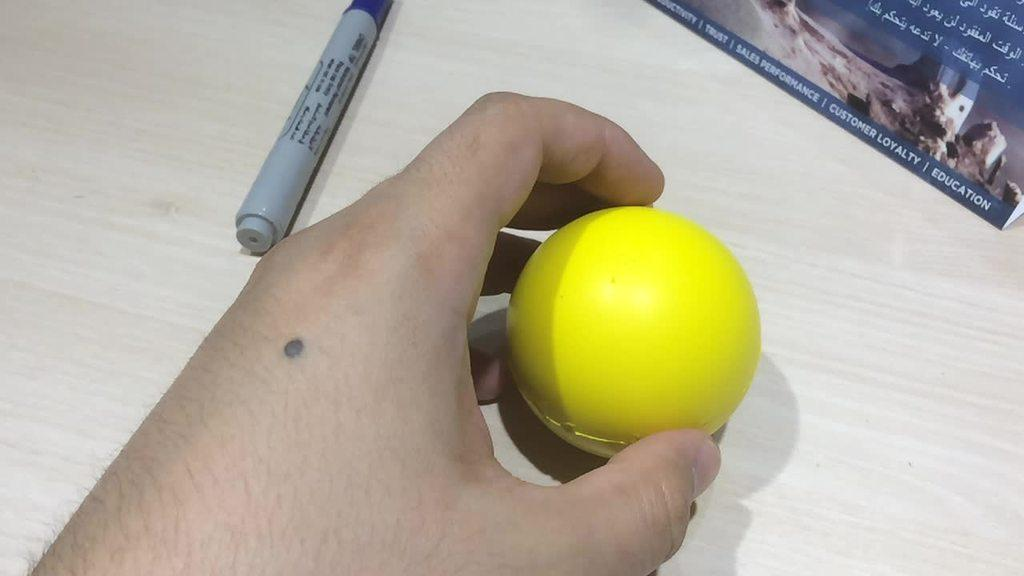What is the hand holding in the image? The hand is holding a ball in the image. What color is the ball? The ball is yellow. What object is at the top of the image? There is a marker at the top of the image. What can be seen in the top right corner of the image? There is a card in the top right corner of the image. How many feet are visible in the image? There are no feet visible in the image; it only shows a hand holding a ball. What type of design is featured on the card in the top right corner of the image? The provided facts do not mention any design on the card, so we cannot answer that question. 